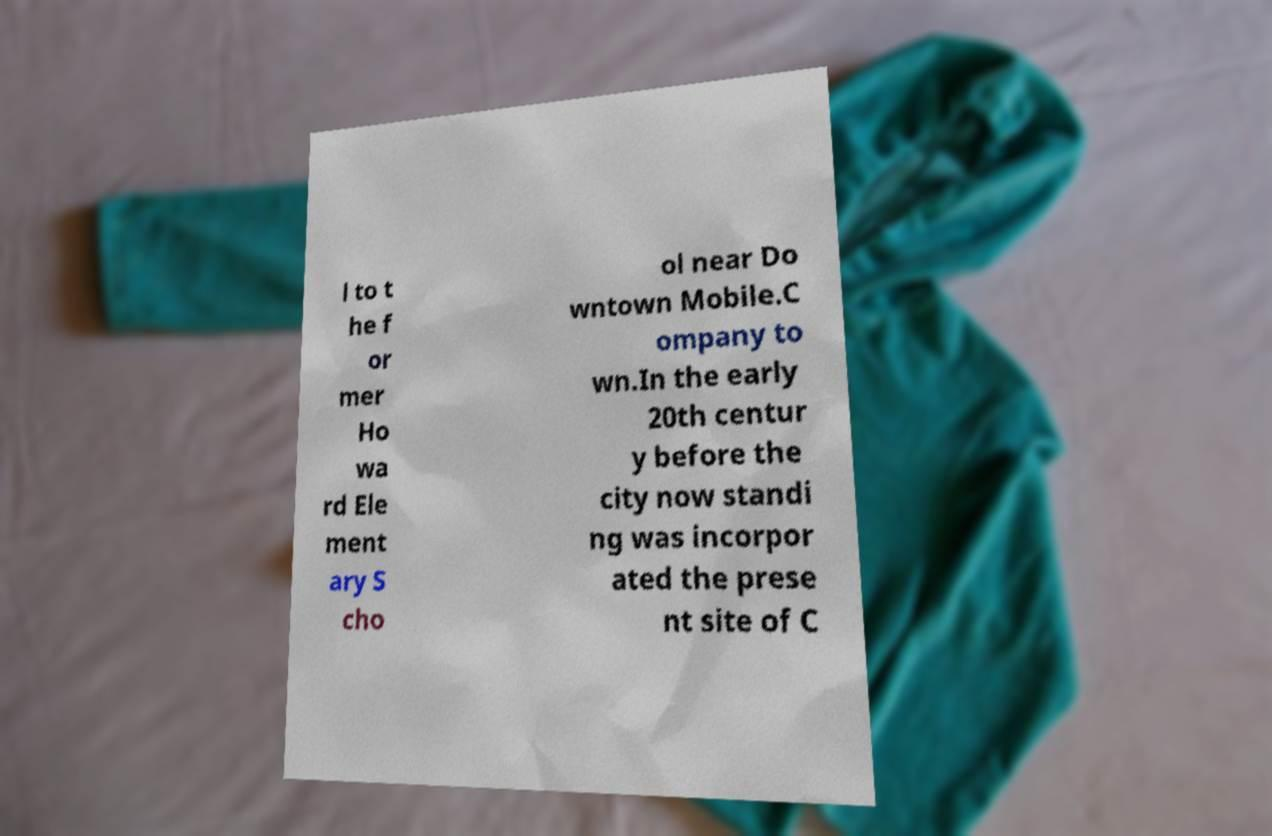Can you read and provide the text displayed in the image?This photo seems to have some interesting text. Can you extract and type it out for me? l to t he f or mer Ho wa rd Ele ment ary S cho ol near Do wntown Mobile.C ompany to wn.In the early 20th centur y before the city now standi ng was incorpor ated the prese nt site of C 